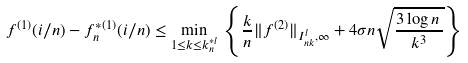<formula> <loc_0><loc_0><loc_500><loc_500>f ^ { ( 1 ) } ( i / n ) - f _ { n } ^ { * ( 1 ) } ( i / n ) \leq \min _ { 1 \leq k \leq k ^ { * l } _ { n } } \, \left \{ \frac { k } { n } \| f ^ { ( 2 ) } \| _ { I _ { n k } ^ { l } , \infty } + 4 \sigma n \sqrt { \frac { 3 \log n \, } { k ^ { 3 } } } \right \}</formula> 